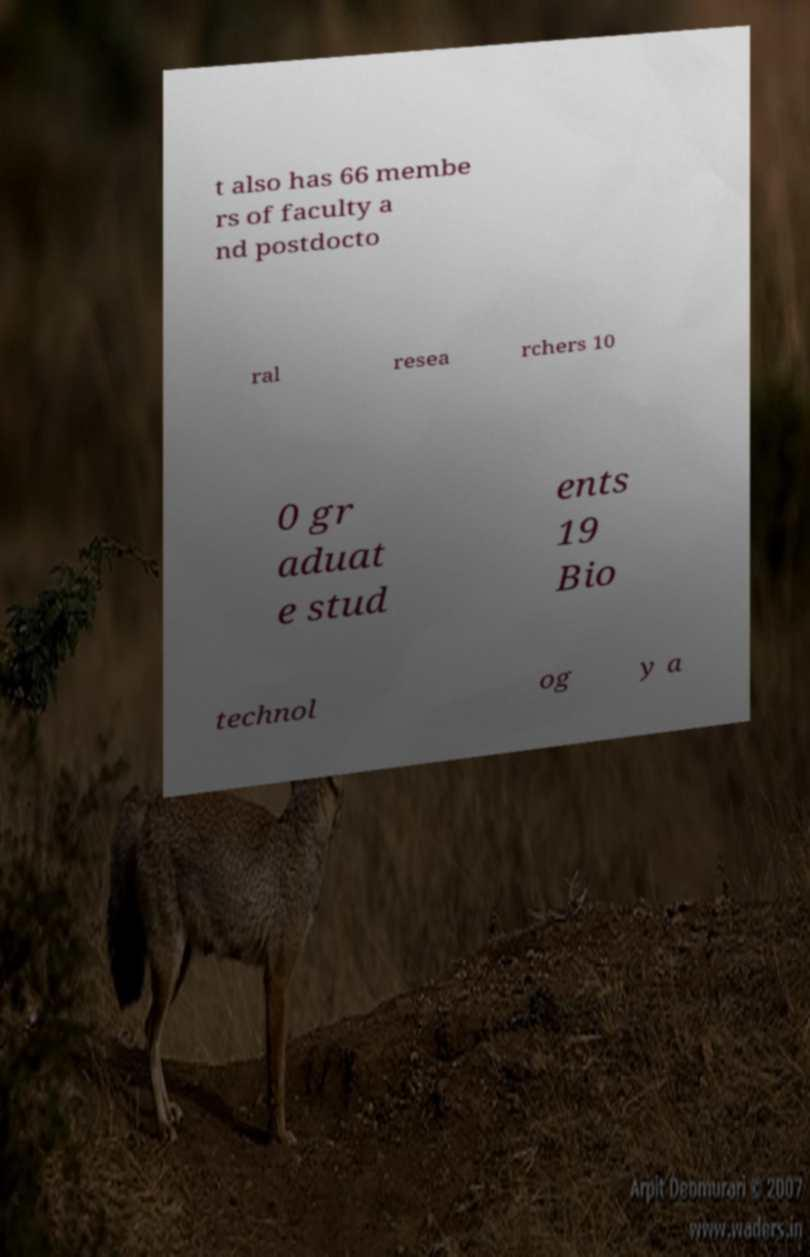There's text embedded in this image that I need extracted. Can you transcribe it verbatim? t also has 66 membe rs of faculty a nd postdocto ral resea rchers 10 0 gr aduat e stud ents 19 Bio technol og y a 